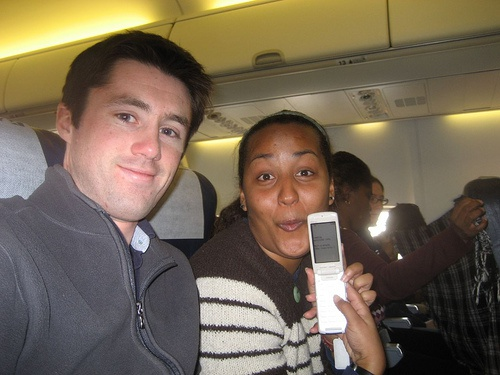Describe the objects in this image and their specific colors. I can see people in olive, gray, black, and lightpink tones, people in olive, black, lightgray, brown, and maroon tones, people in olive, black, maroon, and gray tones, cell phone in olive, white, gray, darkgray, and black tones, and people in olive, black, and gray tones in this image. 